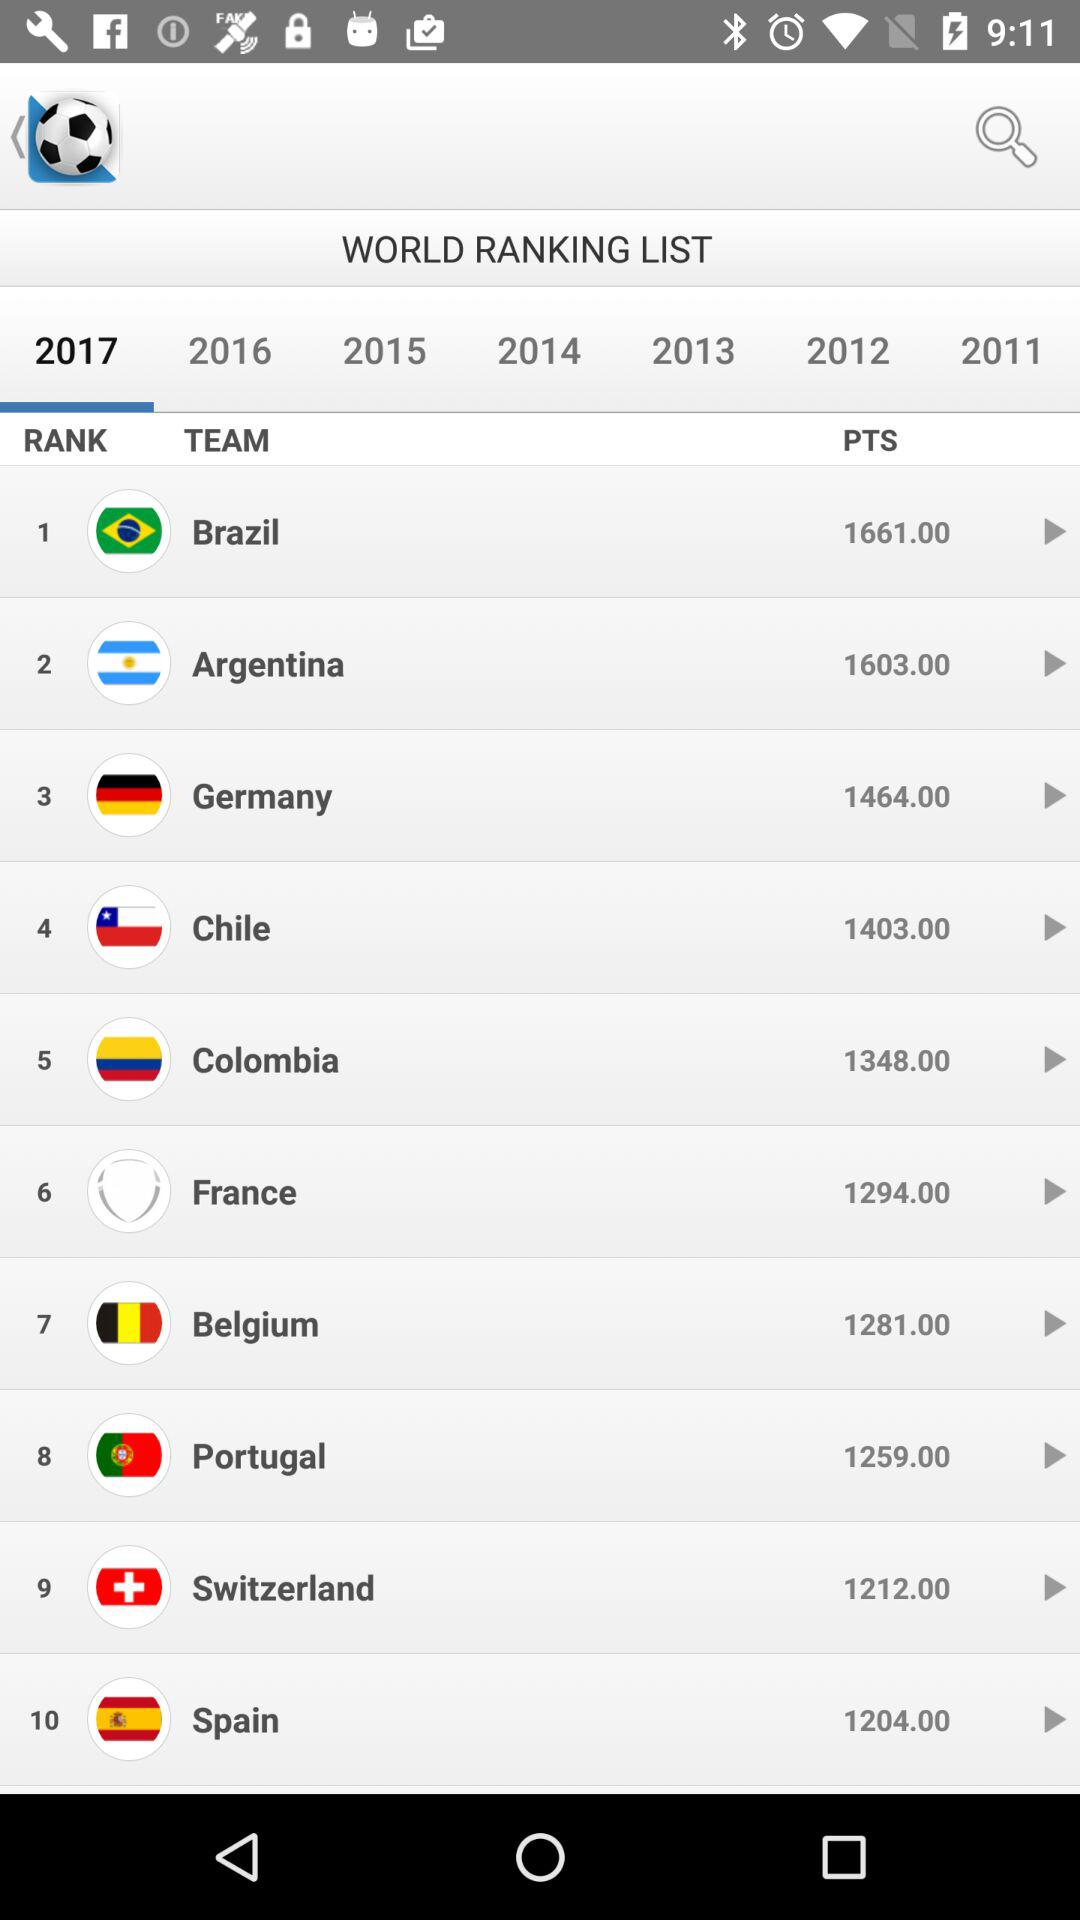Which year has been selected? The selected year is 2017. 